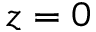<formula> <loc_0><loc_0><loc_500><loc_500>z = 0</formula> 